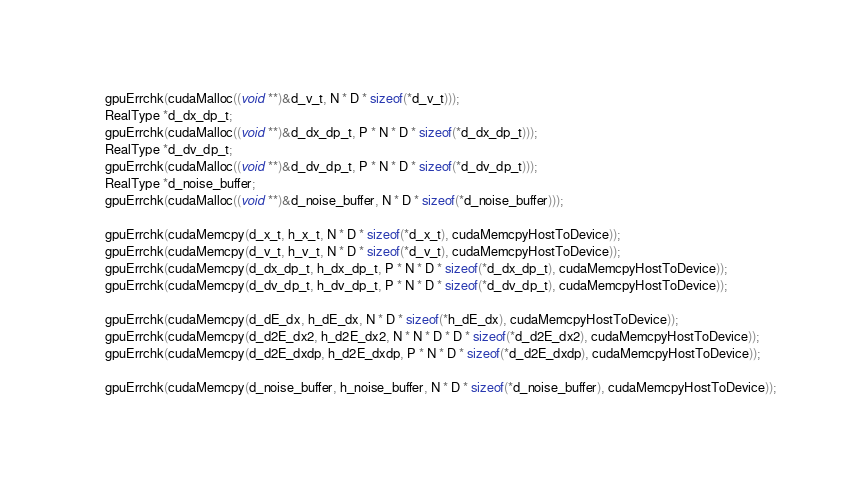Convert code to text. <code><loc_0><loc_0><loc_500><loc_500><_Cuda_>    gpuErrchk(cudaMalloc((void **)&d_v_t, N * D * sizeof(*d_v_t)));
    RealType *d_dx_dp_t;
    gpuErrchk(cudaMalloc((void **)&d_dx_dp_t, P * N * D * sizeof(*d_dx_dp_t)));
    RealType *d_dv_dp_t;
    gpuErrchk(cudaMalloc((void **)&d_dv_dp_t, P * N * D * sizeof(*d_dv_dp_t)));
    RealType *d_noise_buffer;
    gpuErrchk(cudaMalloc((void **)&d_noise_buffer, N * D * sizeof(*d_noise_buffer)));

    gpuErrchk(cudaMemcpy(d_x_t, h_x_t, N * D * sizeof(*d_x_t), cudaMemcpyHostToDevice));
    gpuErrchk(cudaMemcpy(d_v_t, h_v_t, N * D * sizeof(*d_v_t), cudaMemcpyHostToDevice));
    gpuErrchk(cudaMemcpy(d_dx_dp_t, h_dx_dp_t, P * N * D * sizeof(*d_dx_dp_t), cudaMemcpyHostToDevice));
    gpuErrchk(cudaMemcpy(d_dv_dp_t, h_dv_dp_t, P * N * D * sizeof(*d_dv_dp_t), cudaMemcpyHostToDevice));

    gpuErrchk(cudaMemcpy(d_dE_dx, h_dE_dx, N * D * sizeof(*h_dE_dx), cudaMemcpyHostToDevice));
    gpuErrchk(cudaMemcpy(d_d2E_dx2, h_d2E_dx2, N * N * D * D * sizeof(*d_d2E_dx2), cudaMemcpyHostToDevice));
    gpuErrchk(cudaMemcpy(d_d2E_dxdp, h_d2E_dxdp, P * N * D * sizeof(*d_d2E_dxdp), cudaMemcpyHostToDevice));

    gpuErrchk(cudaMemcpy(d_noise_buffer, h_noise_buffer, N * D * sizeof(*d_noise_buffer), cudaMemcpyHostToDevice));
</code> 